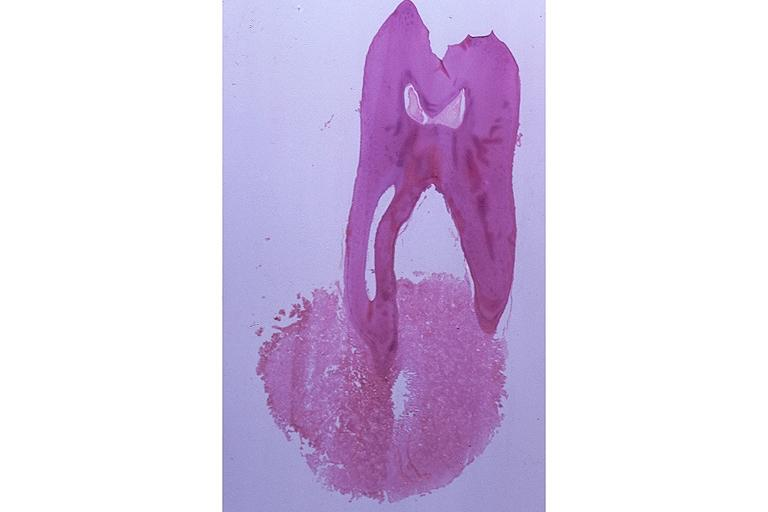what is present?
Answer the question using a single word or phrase. Oral 